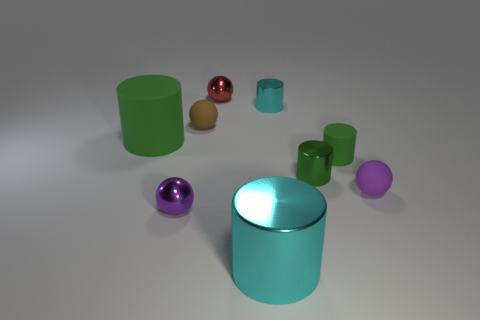What colors are the objects in the image? The objects display a variety of colors including green, blue, purple, and red, with varying shades and sizes. 